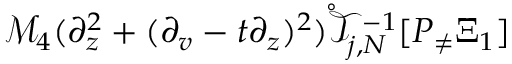<formula> <loc_0><loc_0><loc_500><loc_500>\mathcal { M } _ { 4 } ( \partial _ { z } ^ { 2 } + ( \partial _ { v } - t \partial _ { z } ) ^ { 2 } ) \mathring { \mathcal { T } } _ { j , N } ^ { - 1 } [ P _ { \neq } \Xi _ { 1 } ]</formula> 